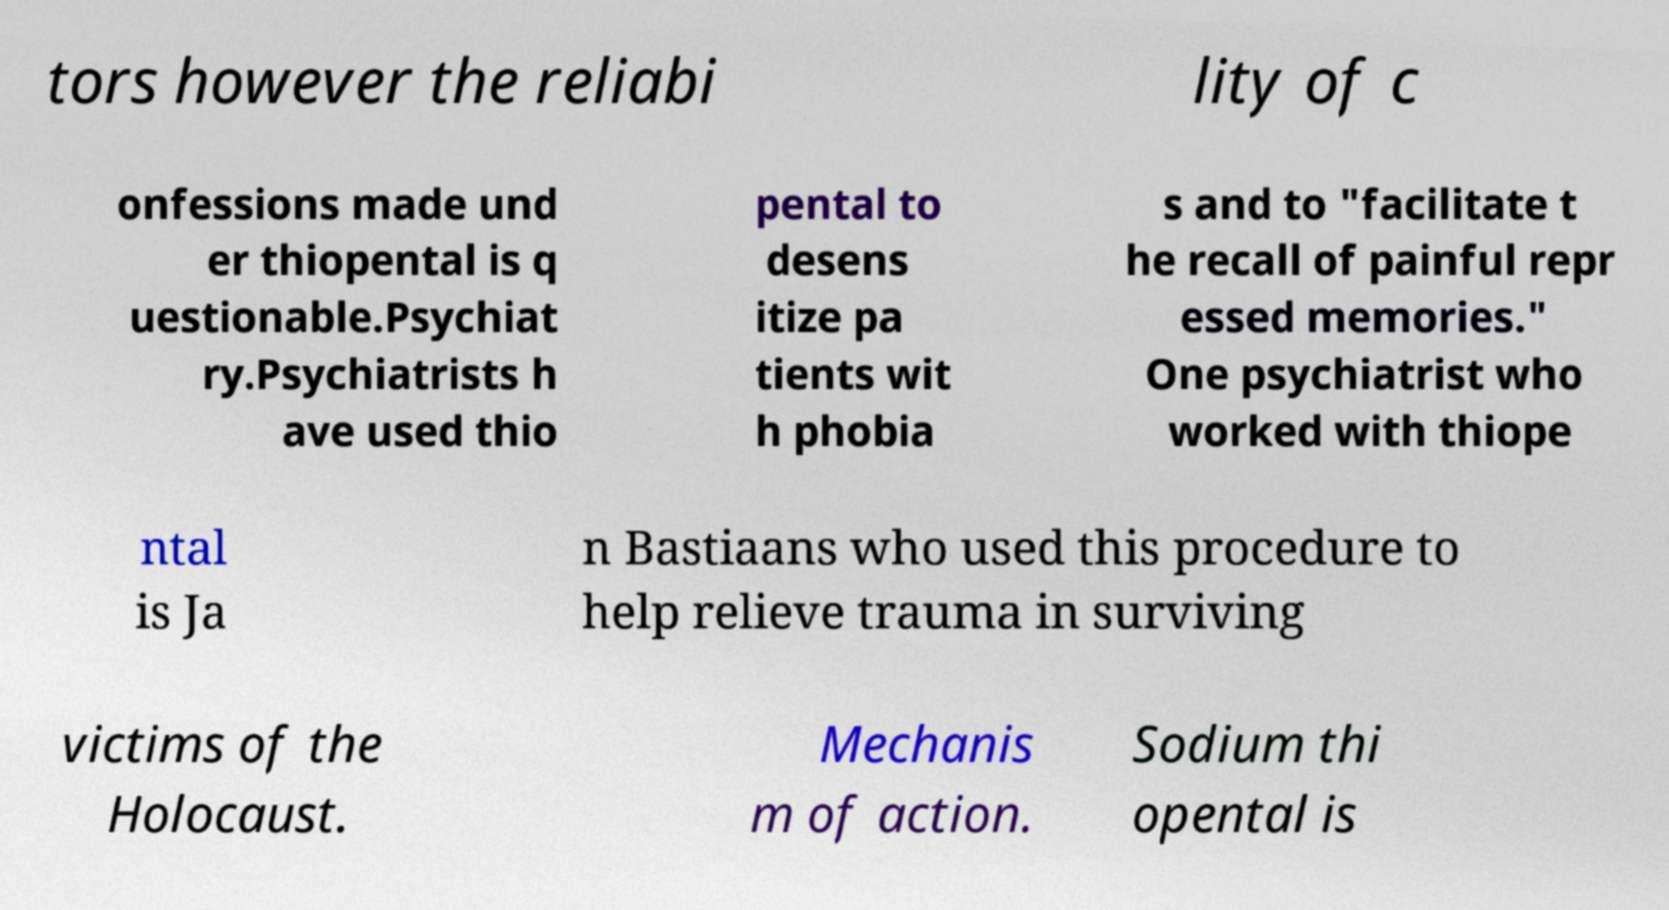There's text embedded in this image that I need extracted. Can you transcribe it verbatim? tors however the reliabi lity of c onfessions made und er thiopental is q uestionable.Psychiat ry.Psychiatrists h ave used thio pental to desens itize pa tients wit h phobia s and to "facilitate t he recall of painful repr essed memories." One psychiatrist who worked with thiope ntal is Ja n Bastiaans who used this procedure to help relieve trauma in surviving victims of the Holocaust. Mechanis m of action. Sodium thi opental is 